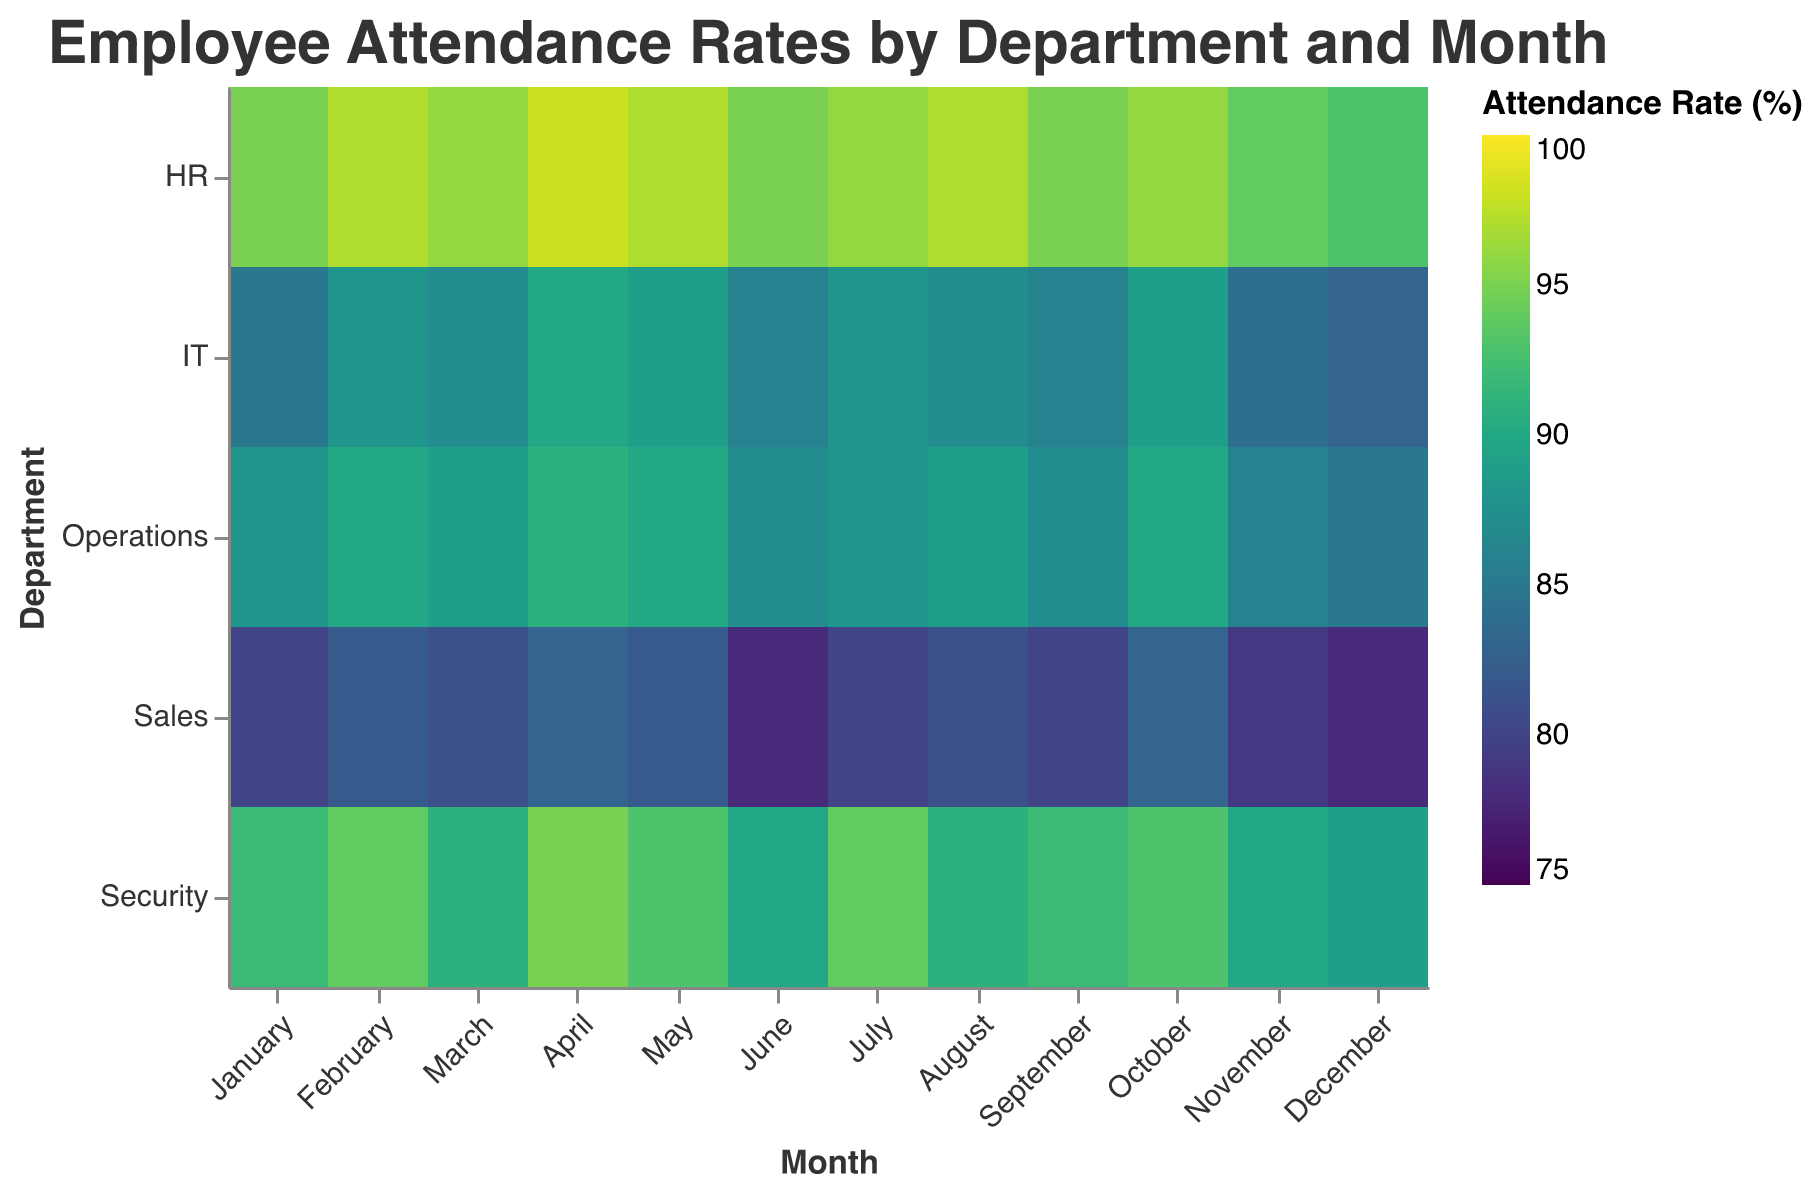What is the title of the heatmap? The title is displayed at the top of the heatmap. It reads, "Employee Attendance Rates by Department and Month."
Answer: Employee Attendance Rates by Department and Month Which month has the lowest attendance rate in the Security department? By looking at the heatmap, the coldest color (representing the lowest attendance rate) in the Security department is in December.
Answer: December Compare the highest attendance rate in HR and Sales for any single month. The highest attendance rate in HR is 98% (April), whereas the highest in Sales is 83% (April, October). Therefore, the highest rate in HR is greater than in Sales.
Answer: HR has a higher rate What is the average attendance rate in the IT department over the year? Sum all attendance rates for the IT department: 85 + 88 + 87 + 90 + 89 + 86 + 88 + 87 + 86 + 89 + 84 + 83 = 1032. Dividing by the number of months (12), the average rate is 1032/12.
Answer: 86 Which department has the most consistent attendance rate, meaning the smallest range between highest and lowest values? For each department, calculate the range:
Security: 95-89=6
IT: 90-83=7
Sales: 83-78=5
HR: 98-93=5
Operations: 91-85=6
Both Sales and HR have the smallest range of 5.
Answer: Sales and HR What month shows the lowest attendance rate overall? The coldest color, indicating the lowest attendance, appears in the Sales department in June and December. It's at 78%.
Answer: June and December How many departments have an average attendance rate above 90%? Calculate the average attendance rate for each department:
Security: (average is 92.08)
IT: (average is 86)
Sales: (average is 80.67)
HR: (average is 95.58)
Operations: (average is 88)
Only Security and HR have averages above 90.
Answer: 2 Which departments show a declining attendance rate from January to December? Observe the trend from January to December for each department:
Security: Yes (92 to 89)
IT: Yes (85 to 83)
Sales: Yes (80 to 78)
HR: Yes (95 to 93)
Operations: Yes (88 to 85)
All five departments show a declining trend.
Answer: All departments 